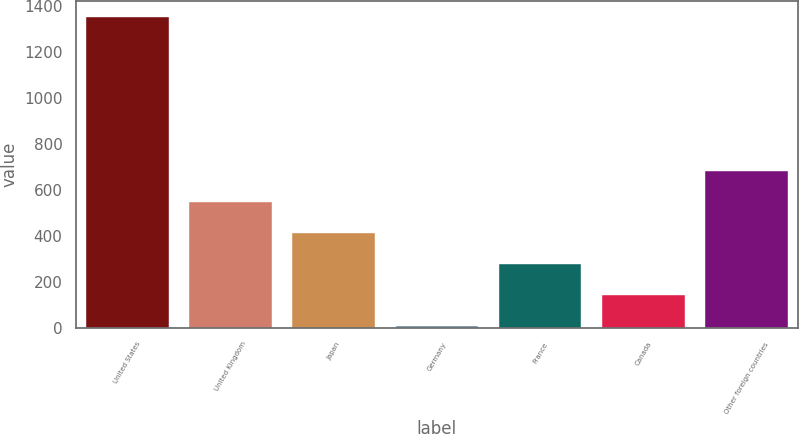<chart> <loc_0><loc_0><loc_500><loc_500><bar_chart><fcel>United States<fcel>United Kingdom<fcel>Japan<fcel>Germany<fcel>France<fcel>Canada<fcel>Other foreign countries<nl><fcel>1351<fcel>545.2<fcel>410.9<fcel>8<fcel>276.6<fcel>142.3<fcel>679.5<nl></chart> 